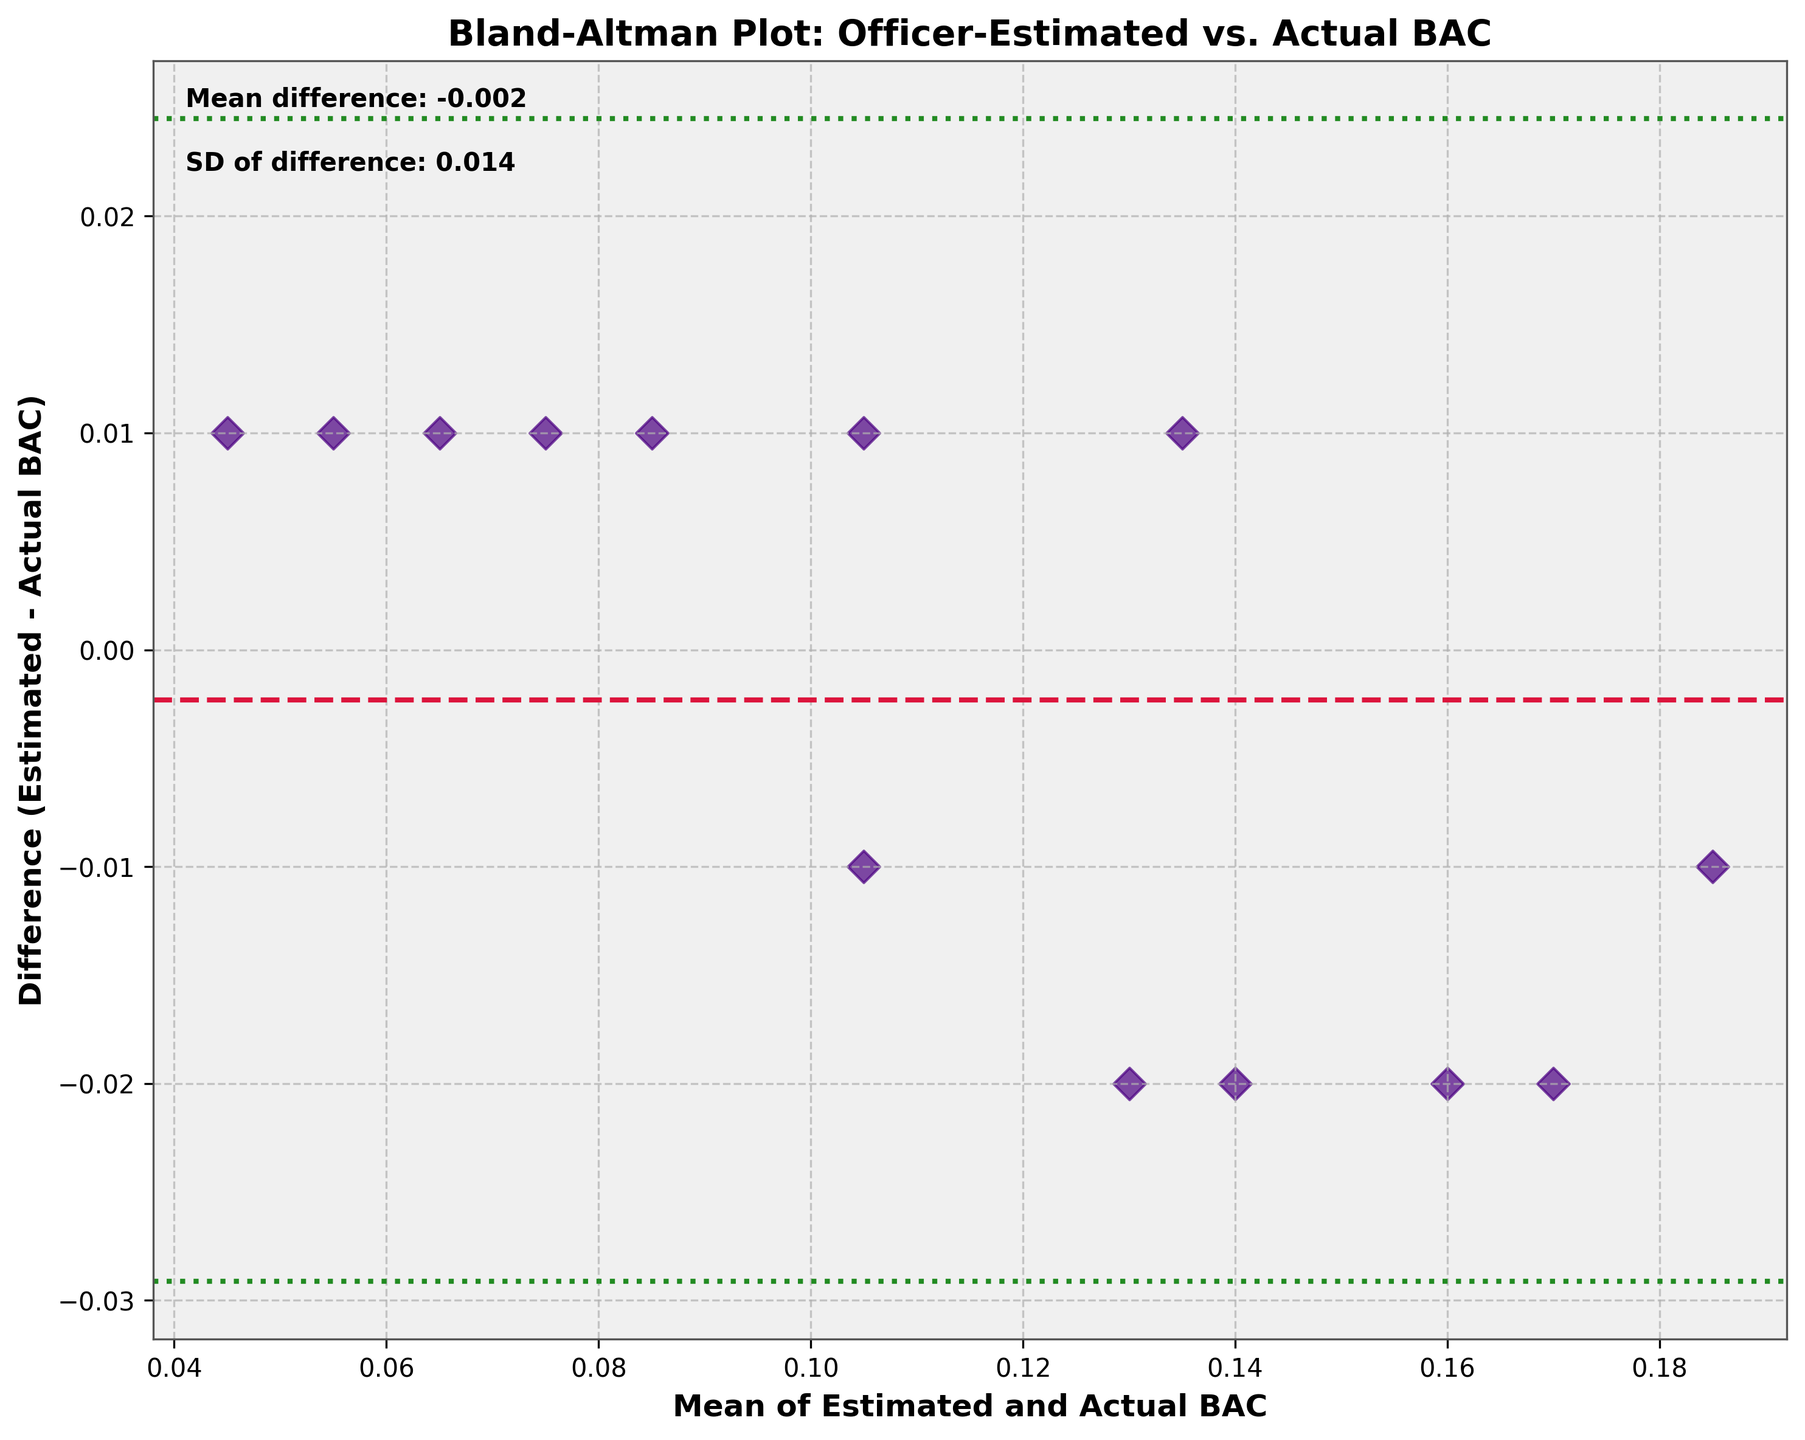What's the title of the plot? The title is prominently displayed at the top of the plot. It usually summarizes the purpose or the main insight of the plot.
Answer: Bland-Altman Plot: Officer-Estimated vs. Actual BAC What are the units on the x-axis? The x-axis label provides information about the metric being represented and its units if applicable.
Answer: Mean of Estimated and Actual BAC What color is used for the data points? Observing the scatter points on the plot will tell us their color.
Answer: Indigo How many data points are plotted? By counting the individual scatter points on the plot, we can determine the total number present.
Answer: 13 What’s the mean difference between estimated and actual BAC? There’s a text annotation on the plot that mentions the mean difference value.
Answer: 0.000 What are the upper and lower limits of agreement? The Bland–Altman plot will typically have lines denoting the limits of agreement, usually ±1.96 times the standard deviation (SD) from the mean difference. The numerical values can be referenced from the plot.
Answer: Upper: 0.047, Lower: -0.047 Which officer had the largest overestimation of BAC from actual? By looking for the scatter point with the highest positive difference between estimated and actual BAC, we can identify this officer.
Answer: Aliya Khasanova Are any data points outside the limits of agreement? Observing the scatter points relative to the limits of agreement lines will show if any points lie beyond these bounds.
Answer: No In general, do officers tend to overestimate or underestimate BAC? Observing the general trend of the scatter points above or below the mean difference line can show the tendency of estimation errors.
Answer: Mixed, but the average is very close to zero What is the standard deviation of the differences? There’s a text annotation on the plot that provides the SD of the differences between estimated and actual BAC.
Answer: 0.024 